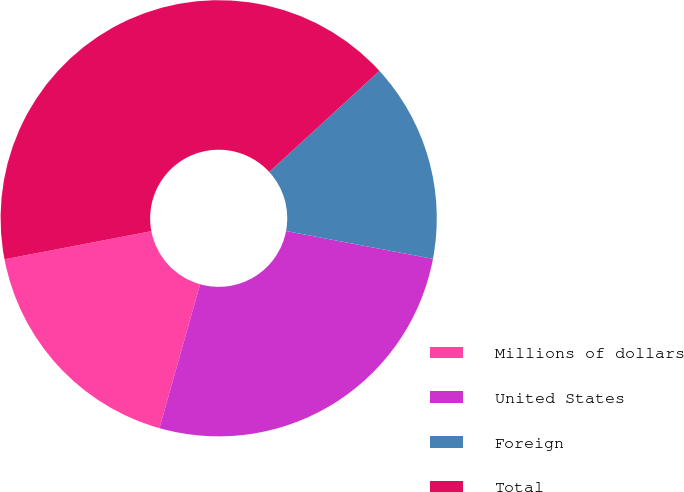Convert chart. <chart><loc_0><loc_0><loc_500><loc_500><pie_chart><fcel>Millions of dollars<fcel>United States<fcel>Foreign<fcel>Total<nl><fcel>17.61%<fcel>26.4%<fcel>14.79%<fcel>41.2%<nl></chart> 